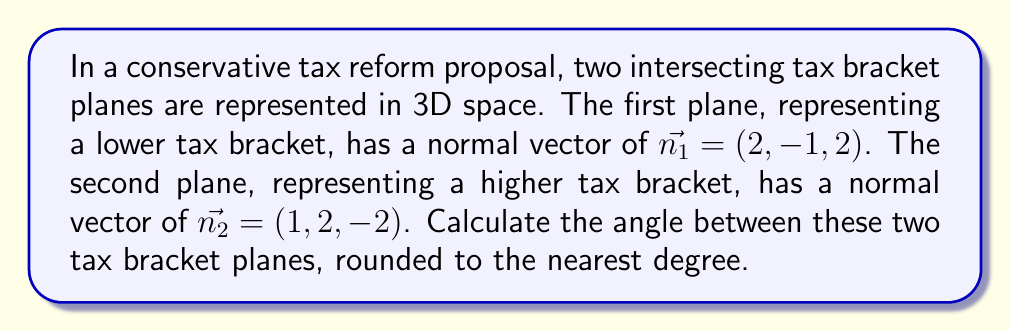Provide a solution to this math problem. To find the angle between two intersecting planes, we can use the angle between their normal vectors. The formula for the angle $\theta$ between two vectors $\vec{a}$ and $\vec{b}$ is:

$$\cos \theta = \frac{\vec{a} \cdot \vec{b}}{|\vec{a}||\vec{b}|}$$

Where $\vec{a} \cdot \vec{b}$ is the dot product of the vectors, and $|\vec{a}|$ and $|\vec{b}|$ are the magnitudes of the vectors.

Step 1: Calculate the dot product of the normal vectors.
$$\vec{n_1} \cdot \vec{n_2} = (2)(1) + (-1)(2) + (2)(-2) = 2 - 2 - 4 = -4$$

Step 2: Calculate the magnitudes of the normal vectors.
$$|\vec{n_1}| = \sqrt{2^2 + (-1)^2 + 2^2} = \sqrt{4 + 1 + 4} = \sqrt{9} = 3$$
$$|\vec{n_2}| = \sqrt{1^2 + 2^2 + (-2)^2} = \sqrt{1 + 4 + 4} = \sqrt{9} = 3$$

Step 3: Apply the formula for the angle between the vectors.
$$\cos \theta = \frac{-4}{(3)(3)} = -\frac{4}{9}$$

Step 4: Take the inverse cosine (arccos) of both sides and convert to degrees.
$$\theta = \arccos(-\frac{4}{9}) \approx 116.4^\circ$$

Step 5: Round to the nearest degree.
$$\theta \approx 116^\circ$$
Answer: The angle between the two tax bracket planes is approximately 116°. 